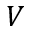<formula> <loc_0><loc_0><loc_500><loc_500>V</formula> 